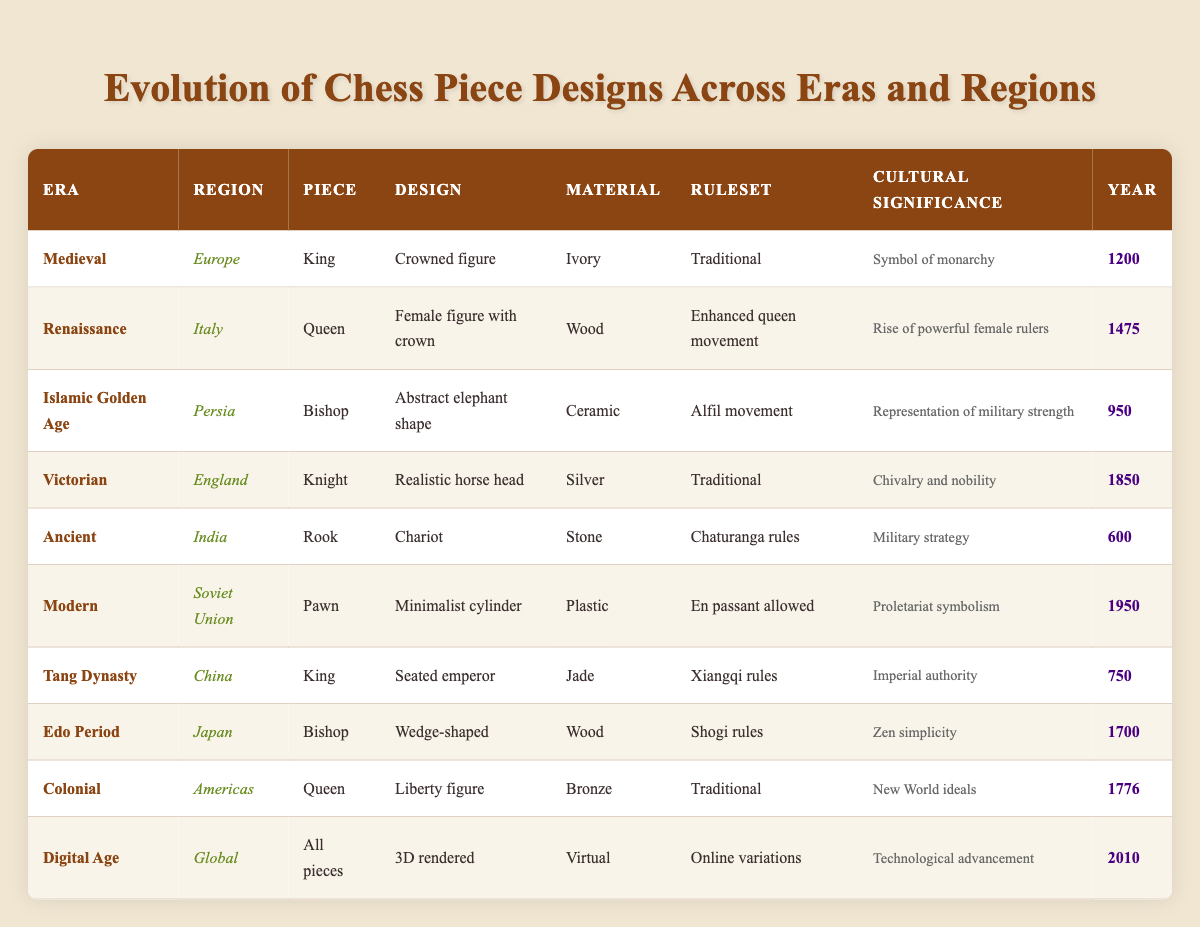What is the design of the King piece from the Medieval era? The table lists the King piece's design in the Medieval era under the "Design" column, which states "Crowned figure." This specific design is repeated in that row.
Answer: Crowned figure Which material was used for the Bishop piece during the Islamic Golden Age? In the row for the Bishop piece within the Islamic Golden Age, the "Material" column indicates it was made of "Ceramic." This can be directly found with no additional calculations needed.
Answer: Ceramic How many pieces were designed with a representation of nobility? To answer this question, I scan the "Cultural Significance" column for indications of nobility. The Knight in Victorian England is highlighted as "Chivalry and nobility," while the Rook from Ancient India discusses "Military strategy," which could relate to nobility but is more indirect. Thus, only one piece explicitly represents nobility.
Answer: 1 Is there a Queen piece in both the Renaissance and the Colonial eras? Examining the table, the Renaissance has a Queen listed with "Female figure with crown," and the Colonial section also features a Queen as a "Liberty figure." Thus, both eras include a Queen piece.
Answer: Yes What was the material for all chess pieces designed in the Digital Age? The table specifies that in the Digital Age, the "Material" column states "Virtual." Since the question refers to all pieces designed during this time, virtual is the only material referenced.
Answer: Virtual How does the design of the Rook from Ancient India differ from the King in Medieval Europe? From the table, the Rook's design is "Chariot," while the Medieval King's design is "Crowned figure." This showcases differing themes, with one representing warfare strategy and the other royalty.
Answer: Chariot vs. Crowned figure Was any piece from the Victorian era designed in material other than silver? The Knight in the Victorian era is the only piece listed, and the material for the Knight is "Silver." Therefore, there are no other materials represented for Victorian era pieces.
Answer: No What is the average year of creation for the Bishop pieces listed in the table? The Bishop pieces are from the Islamic Golden Age (950), the Edo Period (1700), and two separate mentions in respective regions, accumulating the years gives (950 + 1700) = 2650. Dividing by two Bishop pieces yields an average of 1325.
Answer: 1325 